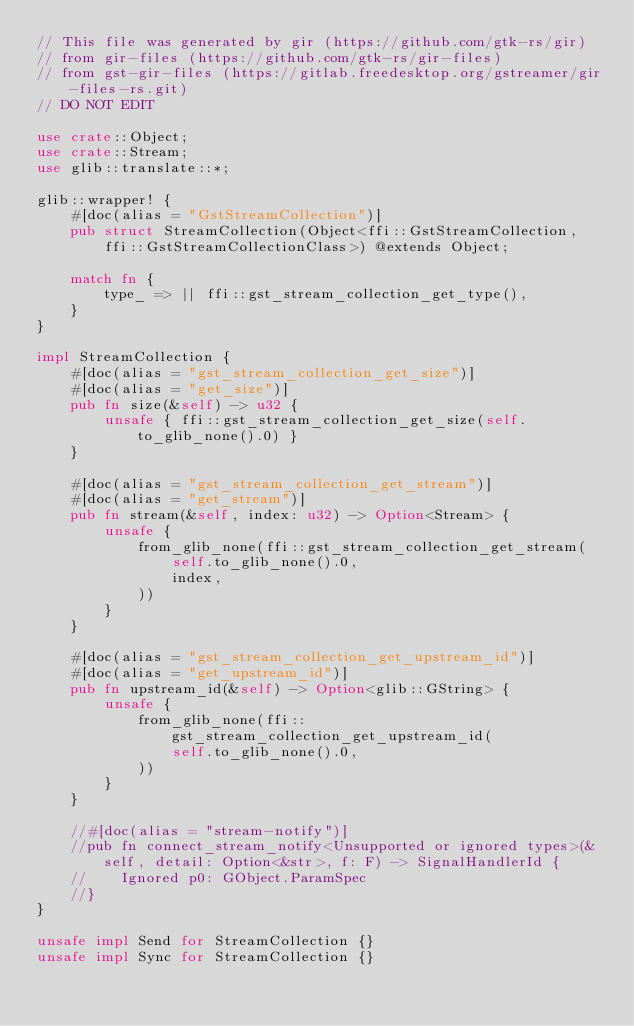Convert code to text. <code><loc_0><loc_0><loc_500><loc_500><_Rust_>// This file was generated by gir (https://github.com/gtk-rs/gir)
// from gir-files (https://github.com/gtk-rs/gir-files)
// from gst-gir-files (https://gitlab.freedesktop.org/gstreamer/gir-files-rs.git)
// DO NOT EDIT

use crate::Object;
use crate::Stream;
use glib::translate::*;

glib::wrapper! {
    #[doc(alias = "GstStreamCollection")]
    pub struct StreamCollection(Object<ffi::GstStreamCollection, ffi::GstStreamCollectionClass>) @extends Object;

    match fn {
        type_ => || ffi::gst_stream_collection_get_type(),
    }
}

impl StreamCollection {
    #[doc(alias = "gst_stream_collection_get_size")]
    #[doc(alias = "get_size")]
    pub fn size(&self) -> u32 {
        unsafe { ffi::gst_stream_collection_get_size(self.to_glib_none().0) }
    }

    #[doc(alias = "gst_stream_collection_get_stream")]
    #[doc(alias = "get_stream")]
    pub fn stream(&self, index: u32) -> Option<Stream> {
        unsafe {
            from_glib_none(ffi::gst_stream_collection_get_stream(
                self.to_glib_none().0,
                index,
            ))
        }
    }

    #[doc(alias = "gst_stream_collection_get_upstream_id")]
    #[doc(alias = "get_upstream_id")]
    pub fn upstream_id(&self) -> Option<glib::GString> {
        unsafe {
            from_glib_none(ffi::gst_stream_collection_get_upstream_id(
                self.to_glib_none().0,
            ))
        }
    }

    //#[doc(alias = "stream-notify")]
    //pub fn connect_stream_notify<Unsupported or ignored types>(&self, detail: Option<&str>, f: F) -> SignalHandlerId {
    //    Ignored p0: GObject.ParamSpec
    //}
}

unsafe impl Send for StreamCollection {}
unsafe impl Sync for StreamCollection {}
</code> 